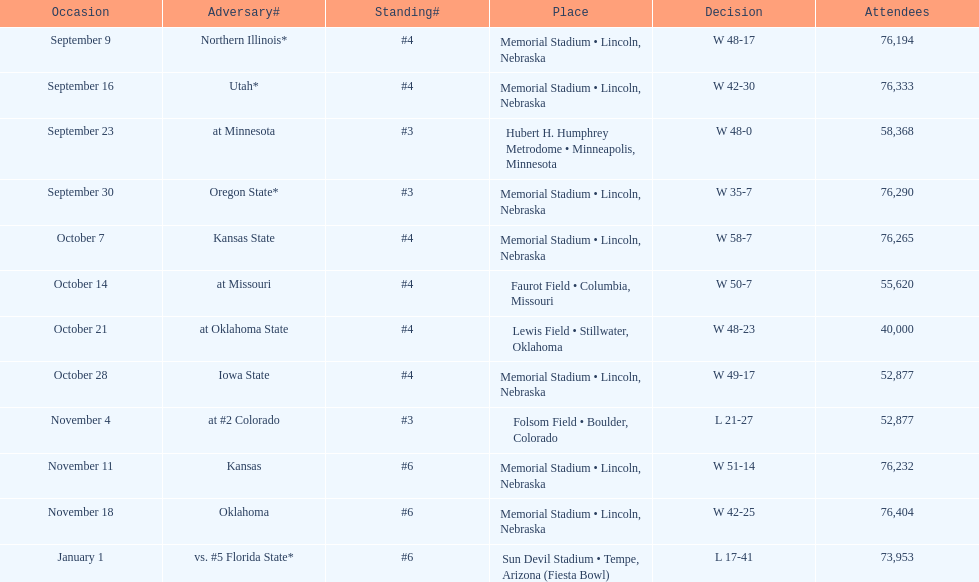Which month is listed the least on this chart? January. 